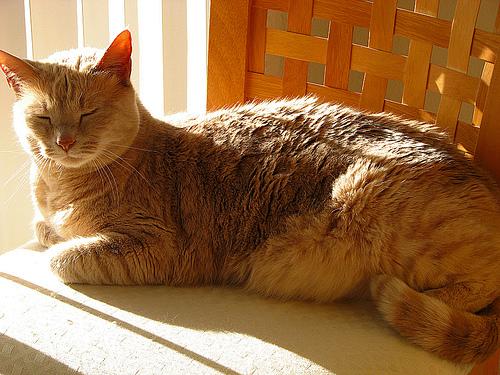Where is the cat looking?
Concise answer only. Nowhere. How many stripes can be seen on the cat's tail?
Be succinct. 3. What color is the cat?
Write a very short answer. Orange. Is the cat awake?
Quick response, please. No. Are the cat's eyes open?
Be succinct. No. 